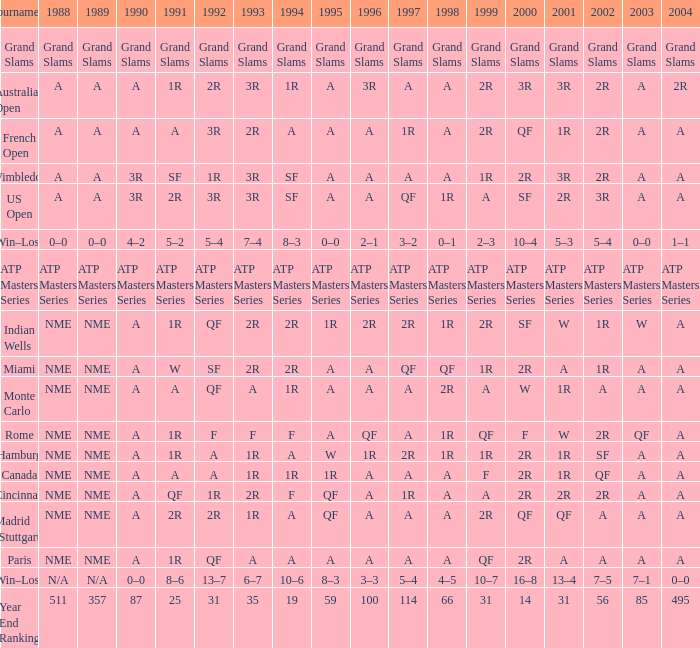What shows for 1992 when 1988 is A, at the Australian Open? 2R. 